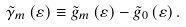<formula> <loc_0><loc_0><loc_500><loc_500>\tilde { \gamma } _ { m } \left ( \varepsilon \right ) \equiv \tilde { g } _ { m } \left ( \varepsilon \right ) - \tilde { g } _ { 0 } \left ( \varepsilon \right ) .</formula> 